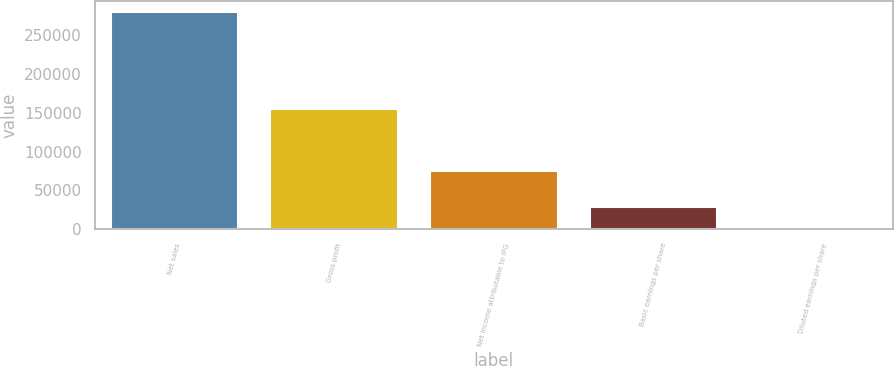Convert chart to OTSL. <chart><loc_0><loc_0><loc_500><loc_500><bar_chart><fcel>Net sales<fcel>Gross profit<fcel>Net income attributable to IPG<fcel>Basic earnings per share<fcel>Diluted earnings per share<nl><fcel>280121<fcel>155336<fcel>75133<fcel>28013.3<fcel>1.39<nl></chart> 